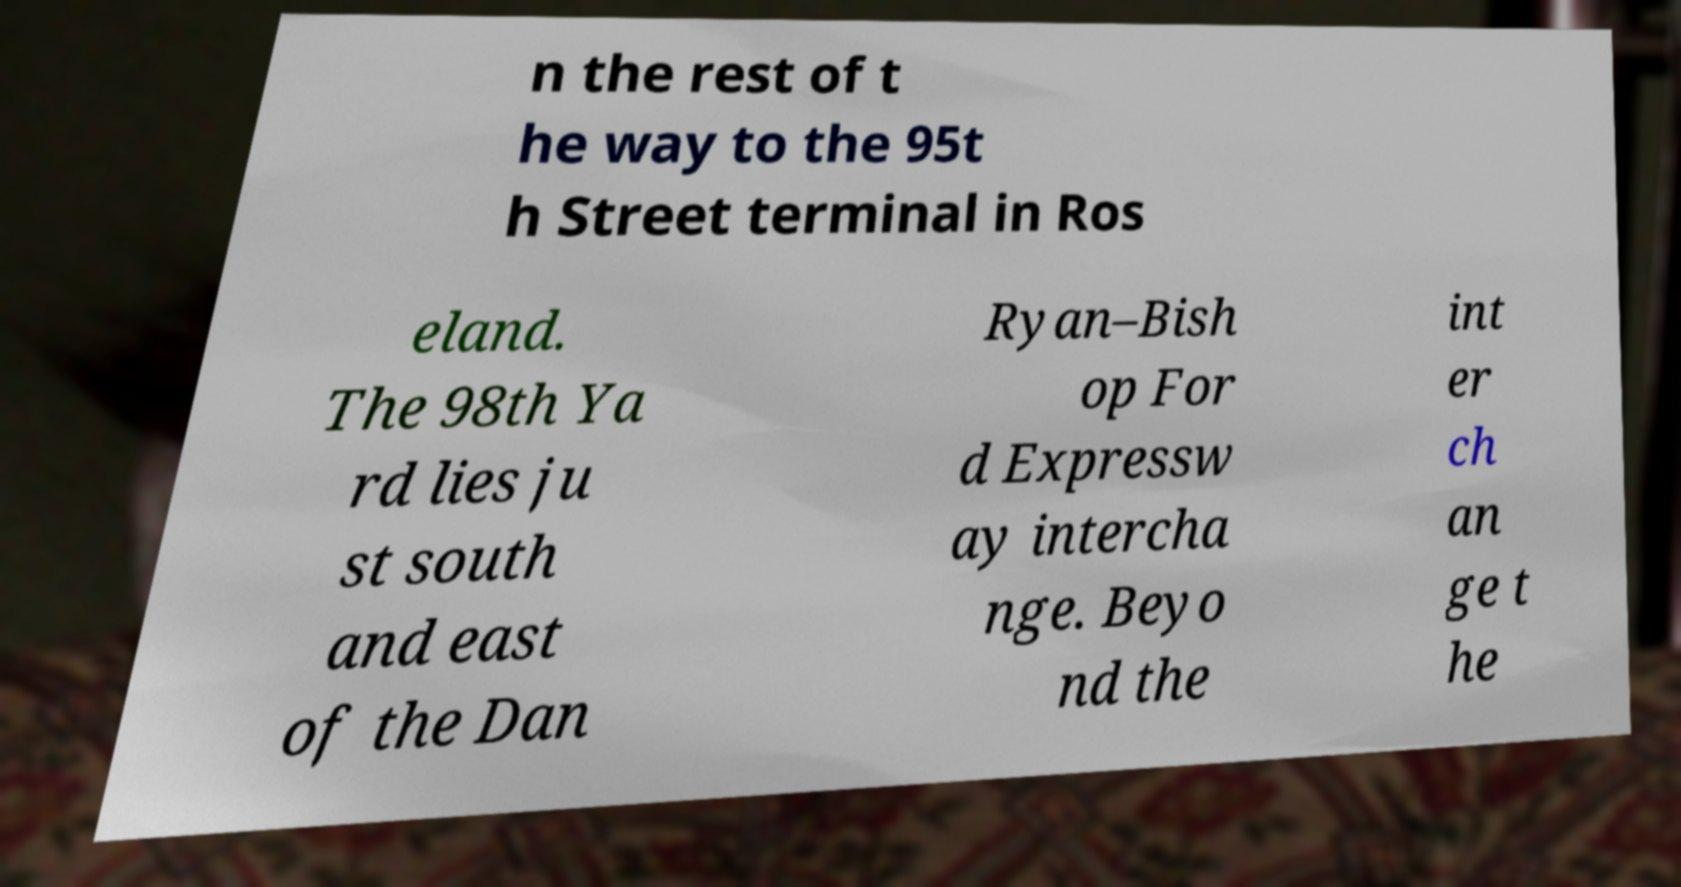For documentation purposes, I need the text within this image transcribed. Could you provide that? n the rest of t he way to the 95t h Street terminal in Ros eland. The 98th Ya rd lies ju st south and east of the Dan Ryan–Bish op For d Expressw ay intercha nge. Beyo nd the int er ch an ge t he 